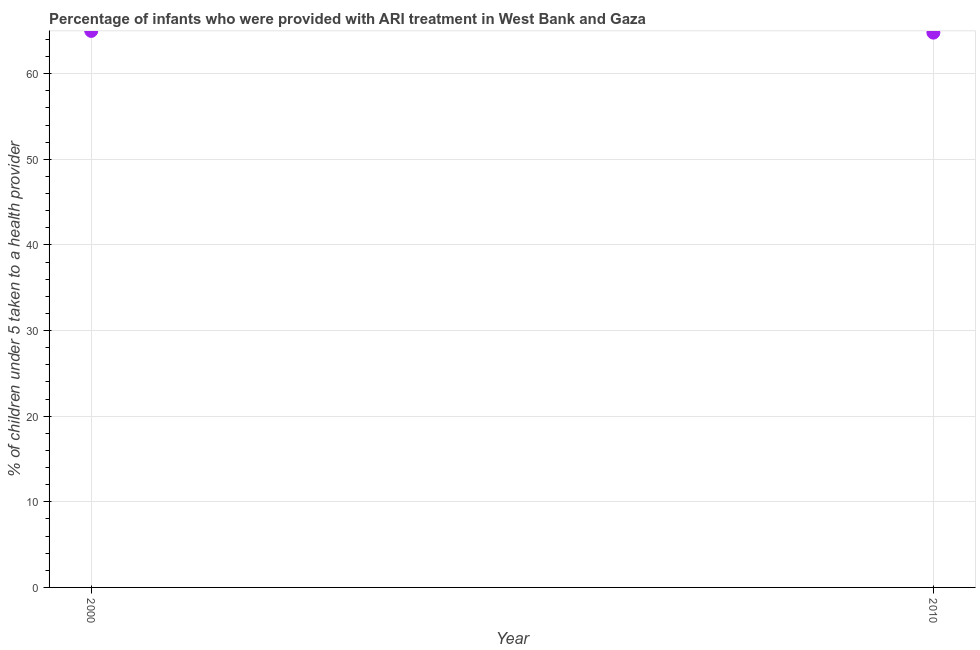Across all years, what is the minimum percentage of children who were provided with ari treatment?
Ensure brevity in your answer.  64.8. In which year was the percentage of children who were provided with ari treatment minimum?
Ensure brevity in your answer.  2010. What is the sum of the percentage of children who were provided with ari treatment?
Ensure brevity in your answer.  129.8. What is the difference between the percentage of children who were provided with ari treatment in 2000 and 2010?
Offer a very short reply. 0.2. What is the average percentage of children who were provided with ari treatment per year?
Give a very brief answer. 64.9. What is the median percentage of children who were provided with ari treatment?
Your answer should be compact. 64.9. Do a majority of the years between 2000 and 2010 (inclusive) have percentage of children who were provided with ari treatment greater than 22 %?
Provide a succinct answer. Yes. What is the ratio of the percentage of children who were provided with ari treatment in 2000 to that in 2010?
Keep it short and to the point. 1. How many dotlines are there?
Give a very brief answer. 1. What is the difference between two consecutive major ticks on the Y-axis?
Make the answer very short. 10. Does the graph contain any zero values?
Your response must be concise. No. Does the graph contain grids?
Offer a terse response. Yes. What is the title of the graph?
Give a very brief answer. Percentage of infants who were provided with ARI treatment in West Bank and Gaza. What is the label or title of the X-axis?
Offer a very short reply. Year. What is the label or title of the Y-axis?
Give a very brief answer. % of children under 5 taken to a health provider. What is the % of children under 5 taken to a health provider in 2000?
Your answer should be very brief. 65. What is the % of children under 5 taken to a health provider in 2010?
Offer a terse response. 64.8. What is the difference between the % of children under 5 taken to a health provider in 2000 and 2010?
Provide a succinct answer. 0.2. What is the ratio of the % of children under 5 taken to a health provider in 2000 to that in 2010?
Provide a short and direct response. 1. 